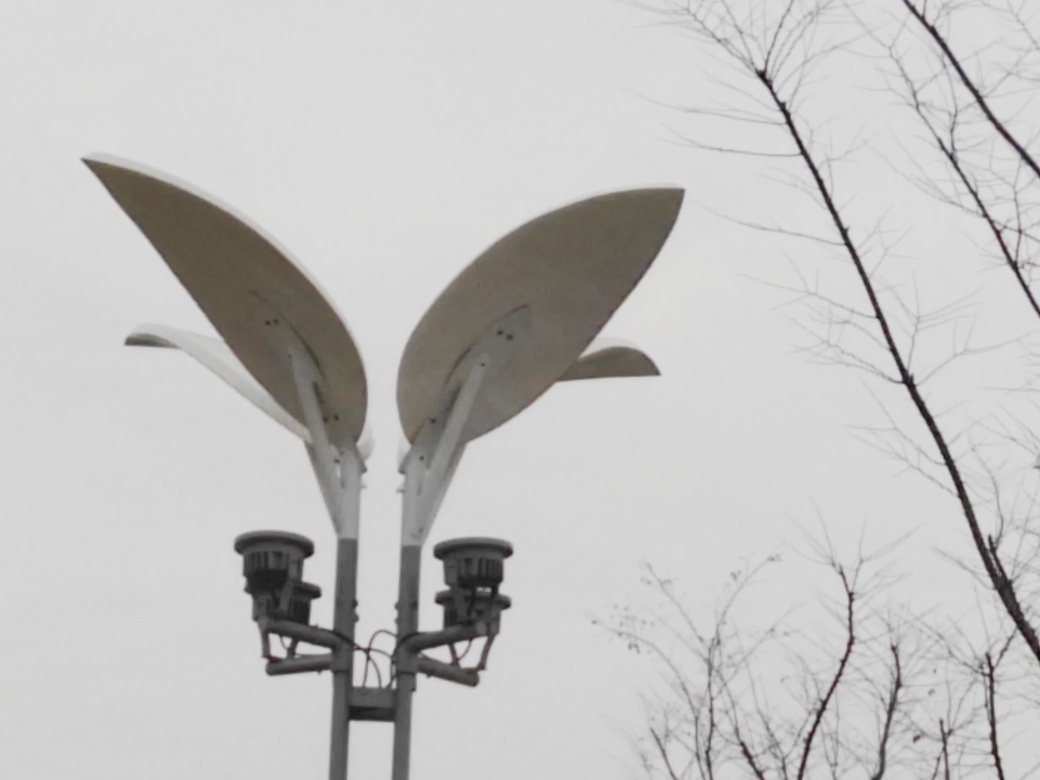How would you characterize the overall colors in this image? A. Vibrant B. Colorful C. Gray D. Bright Answer with the option's letter from the given choices directly. The color palette of the image is primarily muted, with the light fixtures and sky presenting a range of soft neutral tones that suggest an overcast day. The overall impression is neither vibrant nor particularly colorful, hence the accurate characterization is 'C. Gray.' 